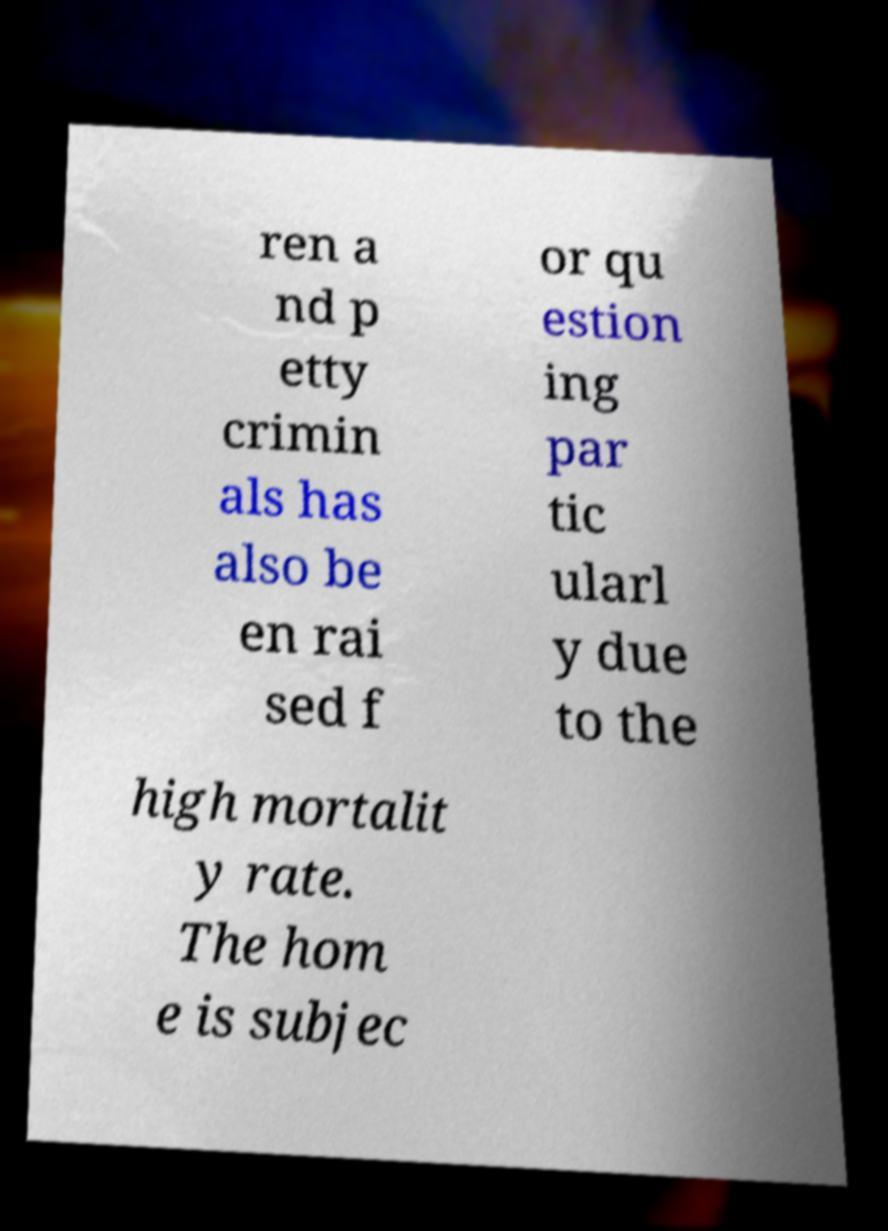Can you accurately transcribe the text from the provided image for me? ren a nd p etty crimin als has also be en rai sed f or qu estion ing par tic ularl y due to the high mortalit y rate. The hom e is subjec 